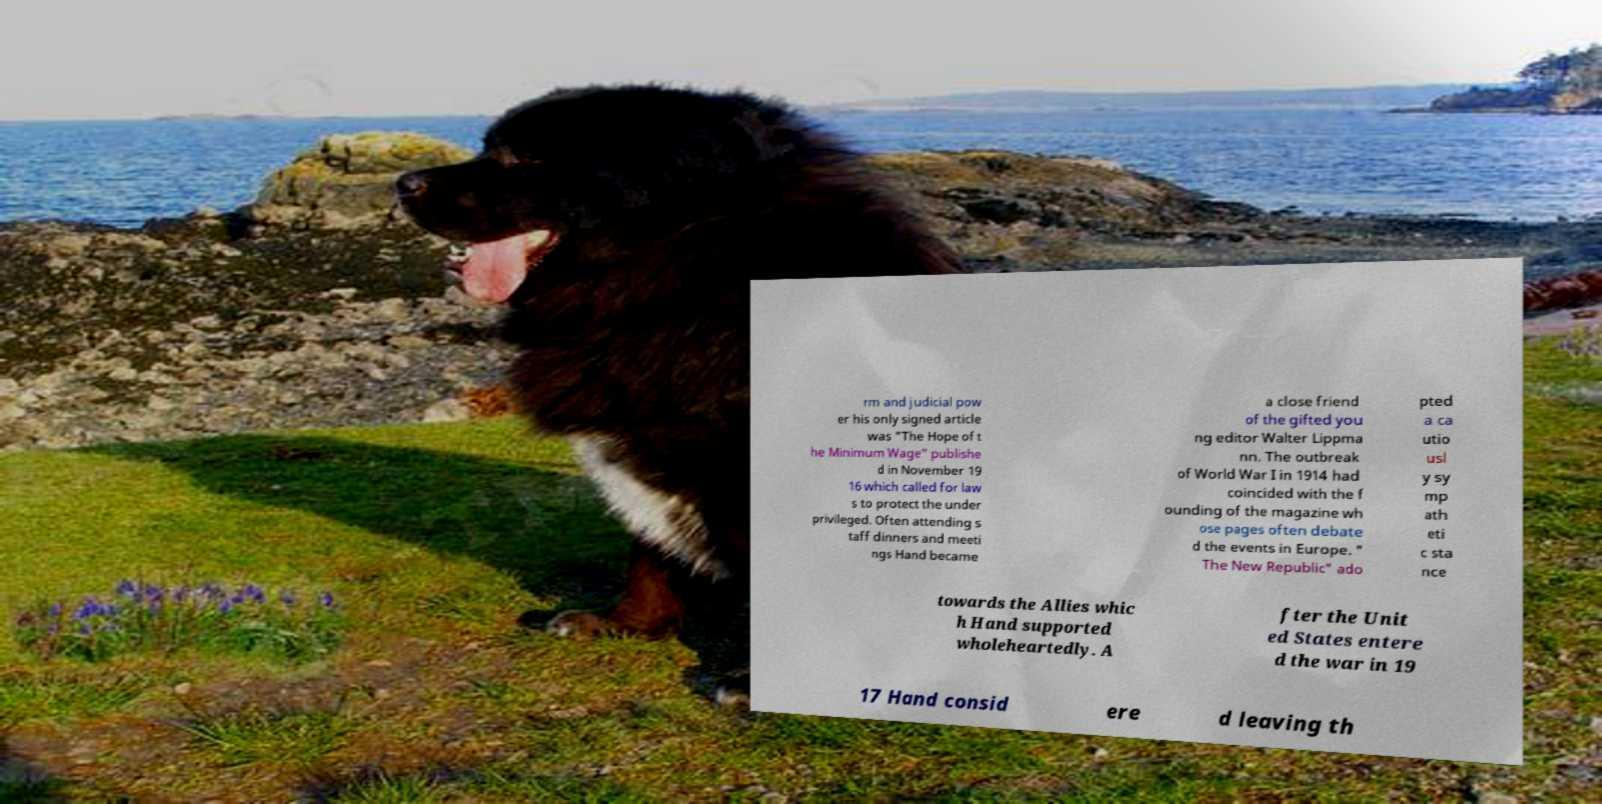Could you extract and type out the text from this image? rm and judicial pow er his only signed article was "The Hope of t he Minimum Wage" publishe d in November 19 16 which called for law s to protect the under privileged. Often attending s taff dinners and meeti ngs Hand became a close friend of the gifted you ng editor Walter Lippma nn. The outbreak of World War I in 1914 had coincided with the f ounding of the magazine wh ose pages often debate d the events in Europe. " The New Republic" ado pted a ca utio usl y sy mp ath eti c sta nce towards the Allies whic h Hand supported wholeheartedly. A fter the Unit ed States entere d the war in 19 17 Hand consid ere d leaving th 